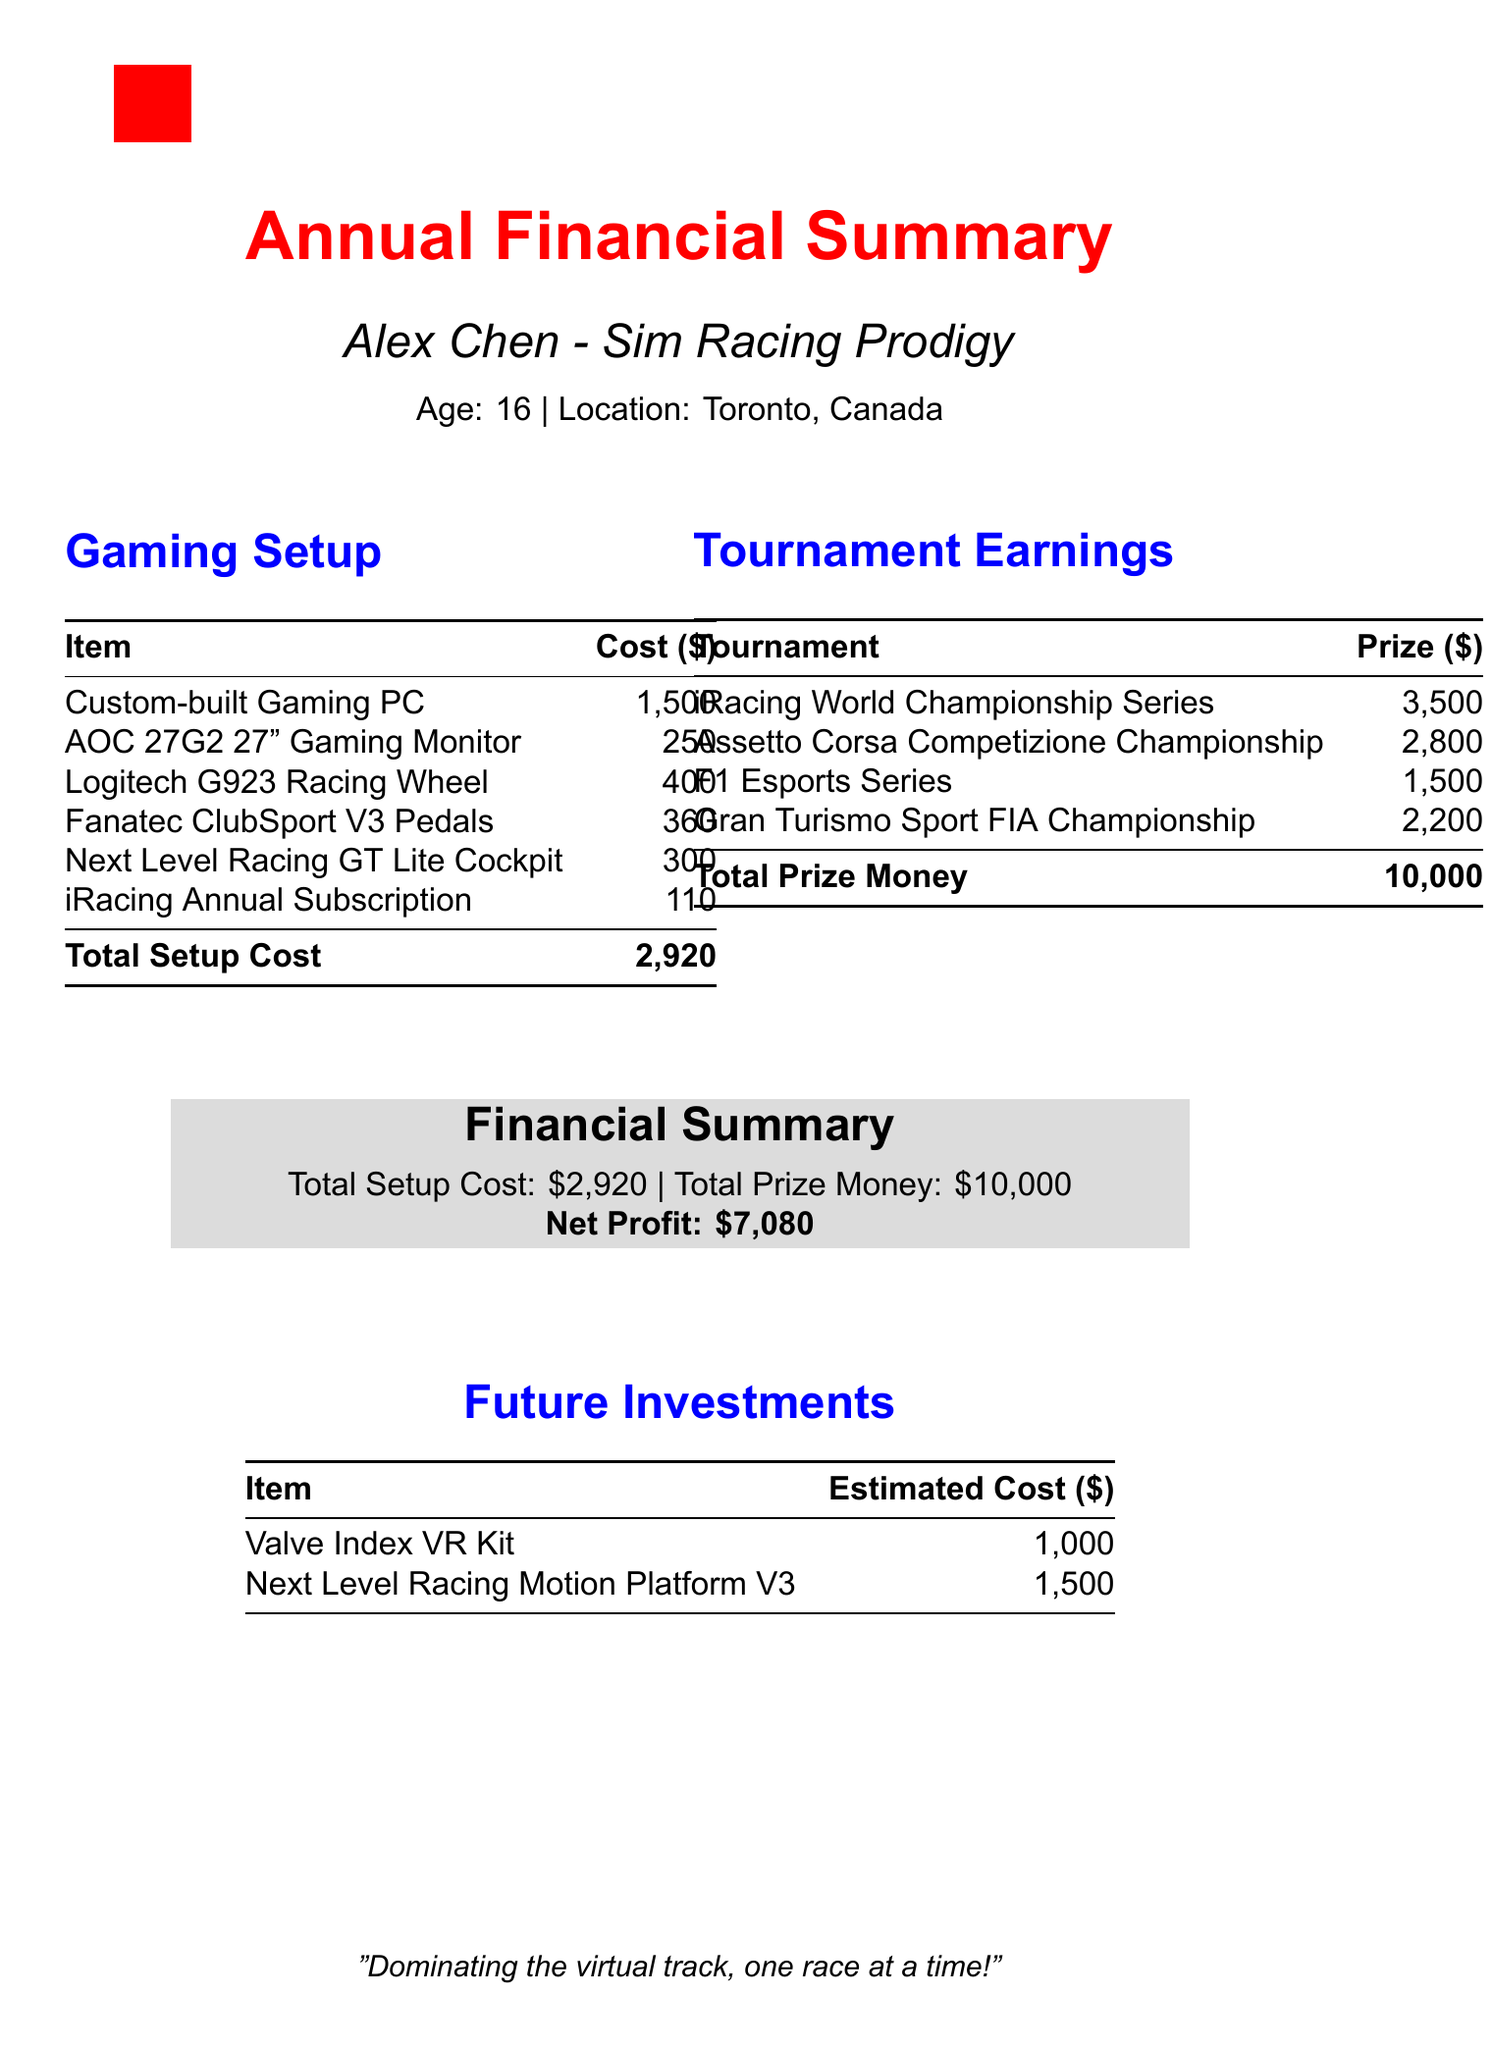what is the total setup cost? The total setup cost is listed at the bottom of the gaming setup section.
Answer: 2,920 what is the total prize money? The total prize money is listed at the bottom of the tournament earnings section.
Answer: 10,000 who is the featured individual in the financial summary? The name of the individual is stated prominently at the top of the document.
Answer: Alex Chen what is the cost of the Logitech G923 Racing Wheel? The cost of the Logitech G923 Racing Wheel is specified in the table of gaming setup costs.
Answer: 400 what is the net profit? The net profit is calculated as total prize money minus total setup cost and is provided in the financial summary.
Answer: 7,080 how much did Alex earn from the iRacing World Championship Series? The prize money for this specific tournament is detailed in the tournament earnings section.
Answer: 3,500 what are the two future investments listed? The future investments are mentioned in a dedicated section with their estimated costs.
Answer: Valve Index VR Kit and Next Level Racing Motion Platform V3 what is the estimated cost of the Next Level Racing Motion Platform V3? The estimated cost is provided in the table under future investments.
Answer: 1,500 which gaming setup item has the lowest cost? This item is determined from the gaming setup table where all costs are listed.
Answer: AOC 27G2 27" Gaming Monitor 